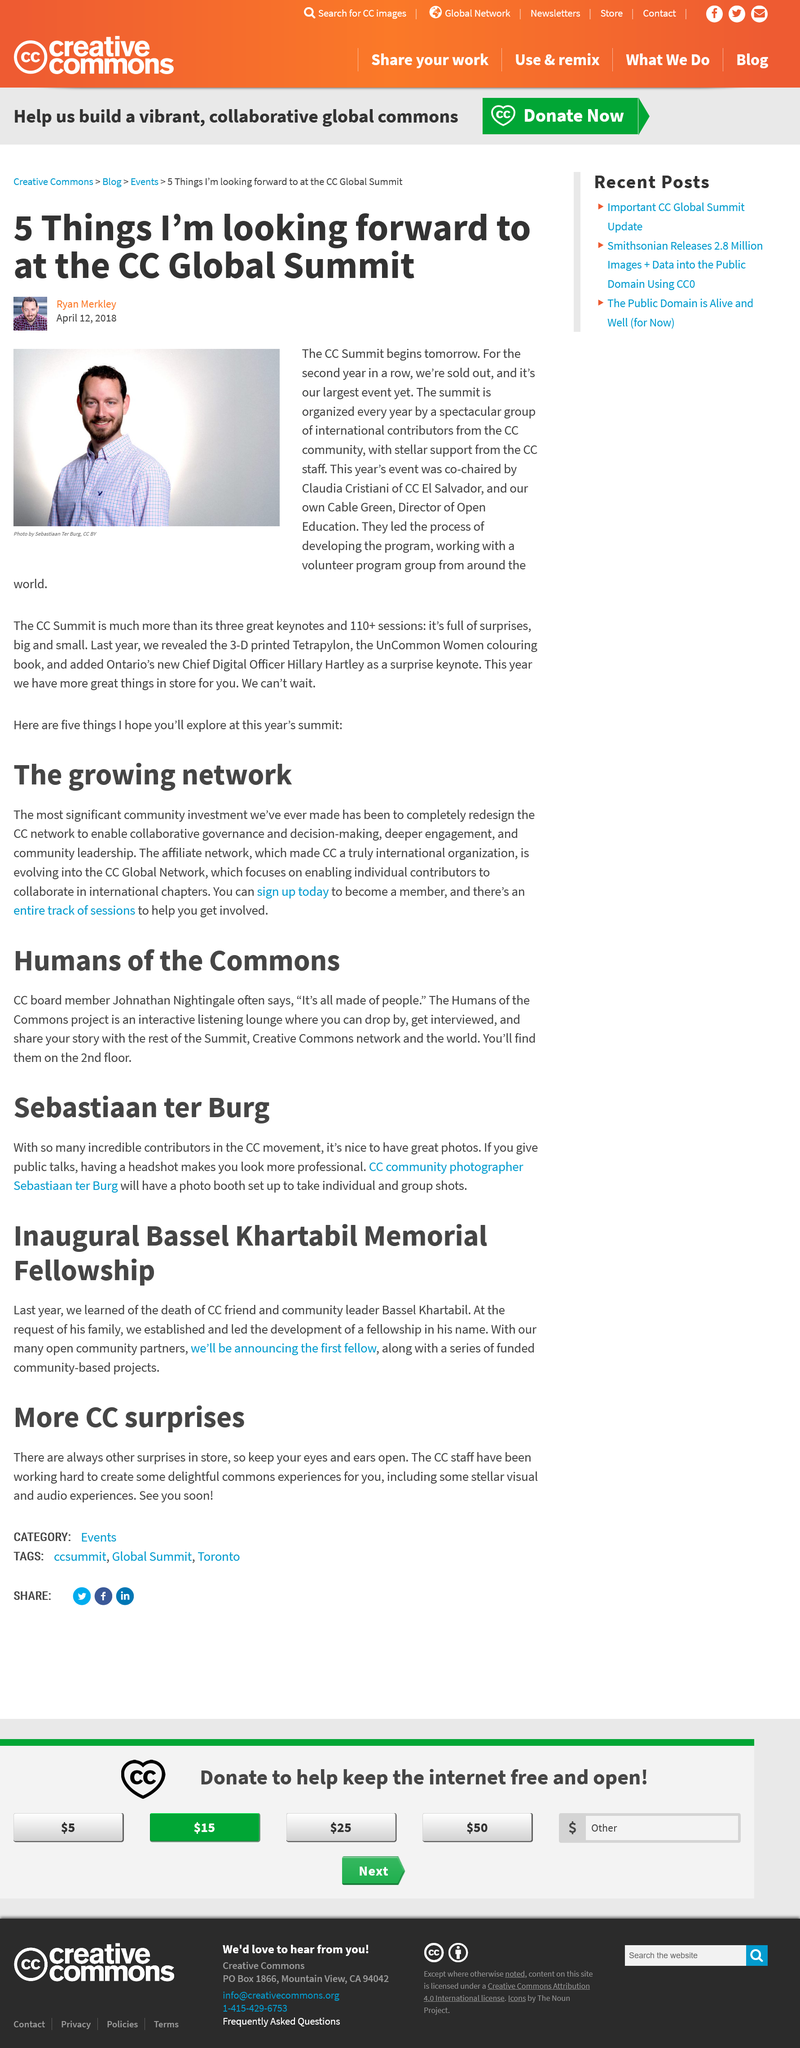Specify some key components in this picture. Claudia Cristiana of CC El Salvador co-chaired this event, with assistance from others. The CC Network offers a track of sessions to help individuals become involved, and the question "How can I get involved in the CC Network?" is a common one. This event has been sold out for two consecutive years. The CC Global Network is focused on empowering individual contributors to work together and collaborate in international chapters, enabling them to achieve their goals and drive meaningful change in their respective communities. The projects are open to the public and community-based. 